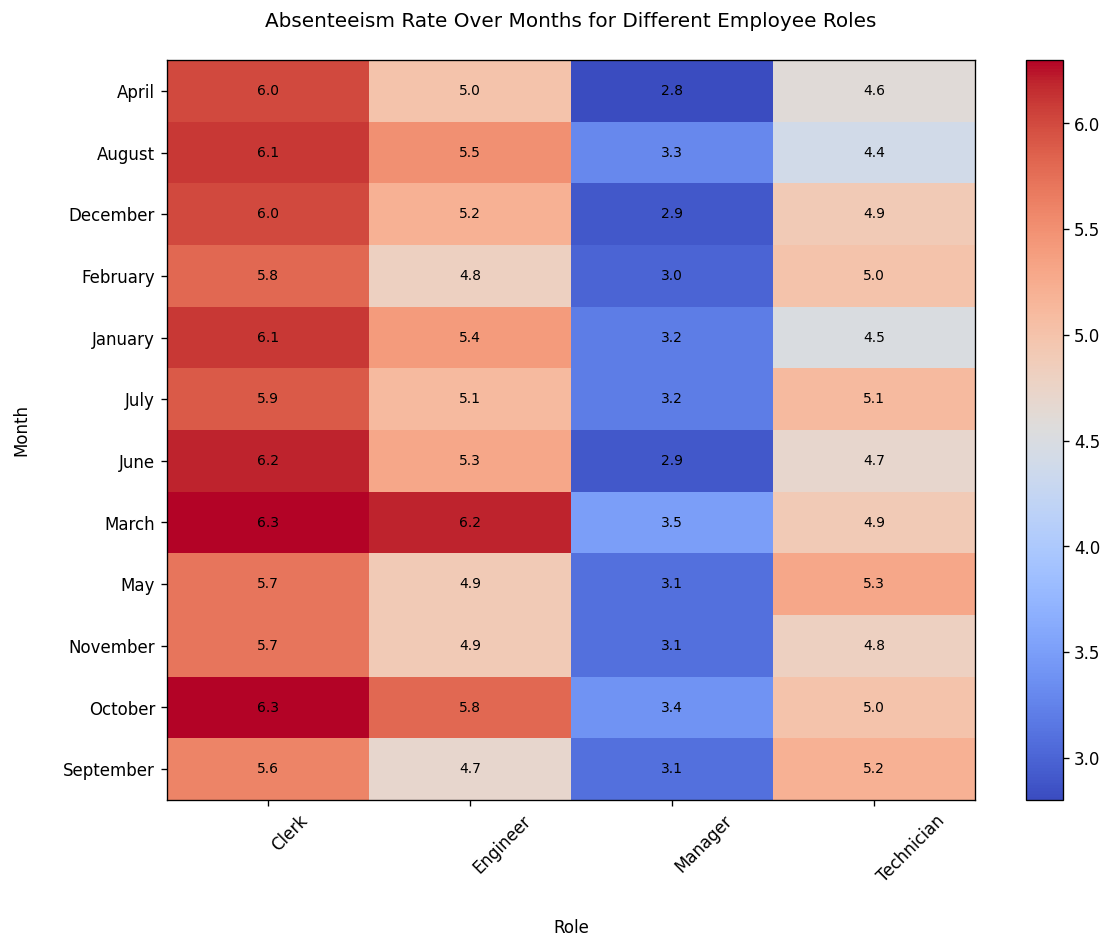What is the absenteeism rate for Engineers in July? Find the cell corresponding to July and Engineer in the heatmap, which shows the absenteeism rate.
Answer: 5.1 Which employee role has the lowest absenteeism rate in March? Look at the March row and find the minimum value among all roles.
Answer: Manager Which month has the highest absenteeism rate for Clerks? Look at the Clerk column and find the month corresponding to the maximum value.
Answer: March and October What's the average absenteeism rate for Managers over the entire year? Sum all absenteeism rates for Managers and divide by the number of months. (3.2 + 3.0 + 3.5 + 2.8 + 3.1 + 2.9 + 3.2 + 3.3 + 3.1 + 3.4 + 3.1 + 2.9) / 12 = 3.1
Answer: 3.1 Is the absenteeism rate for Technicians in September higher or lower compared to June? Compare the value for Technicians in September (5.2) with June (4.7).
Answer: Higher Which role has the most consistent absenteeism rate (least variation) throughout the year? Visually assess which role has the least fluctuation in colors across all months in its column. Alternatively, calculate the variance of absenteeism rates for each role.
Answer: Manager During which month do Engineers have their lowest absenteeism rate? Look at the Engineer column and find the month corresponding to the minimum value.
Answer: September What is the sum of the absenteeism rates for all roles in May? Add the values for all roles in May: 4.9 + 3.1 + 5.3 + 5.7 = 19.0.
Answer: 19.0 